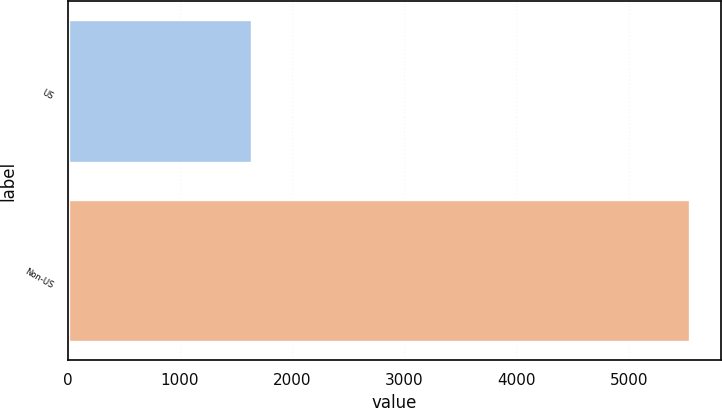Convert chart to OTSL. <chart><loc_0><loc_0><loc_500><loc_500><bar_chart><fcel>US<fcel>Non-US<nl><fcel>1645<fcel>5546<nl></chart> 